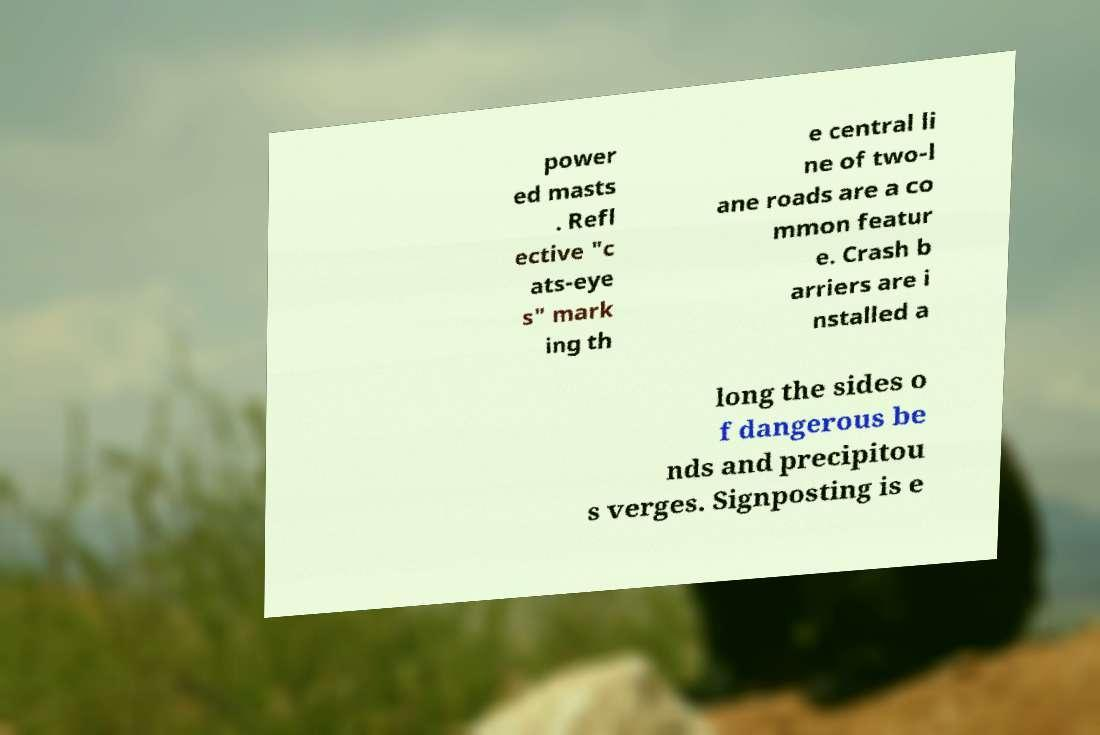What messages or text are displayed in this image? I need them in a readable, typed format. power ed masts . Refl ective "c ats-eye s" mark ing th e central li ne of two-l ane roads are a co mmon featur e. Crash b arriers are i nstalled a long the sides o f dangerous be nds and precipitou s verges. Signposting is e 